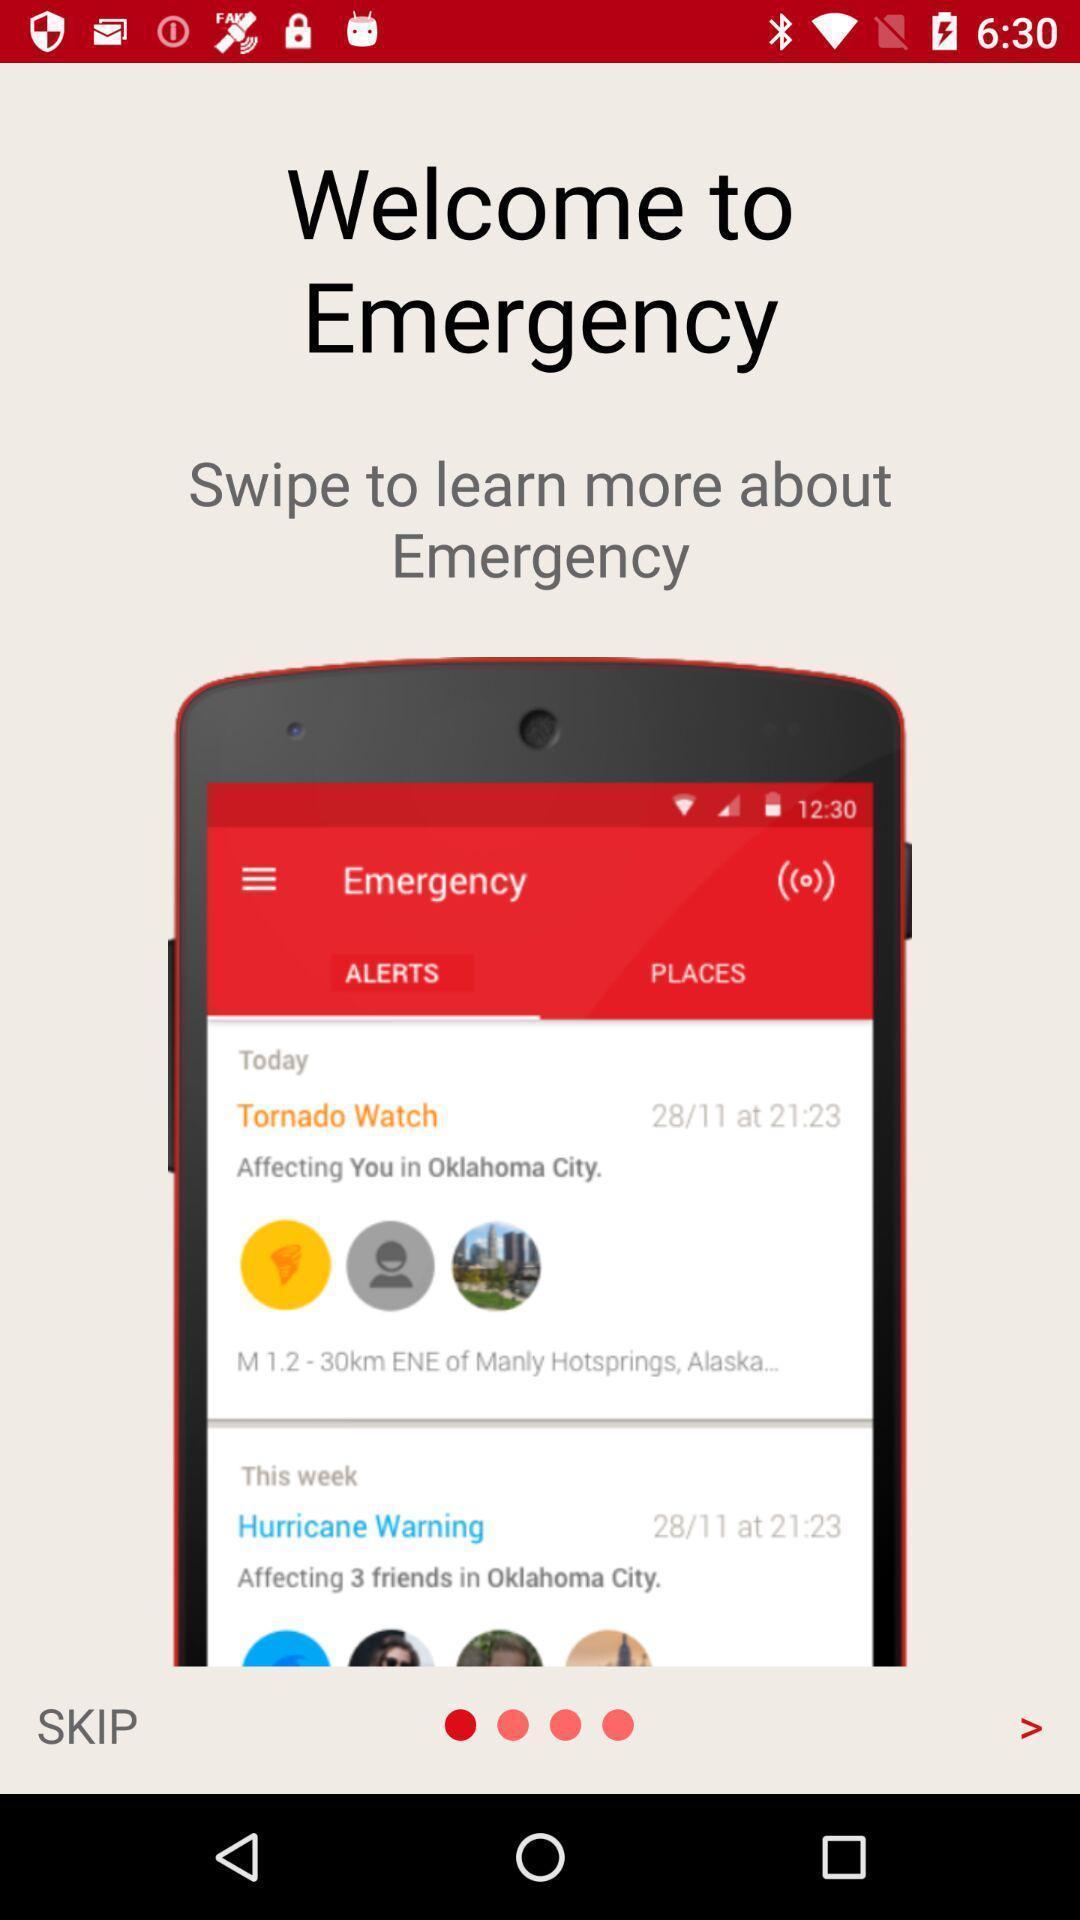Tell me what you see in this picture. Welcome screen with introduction and skip option. 